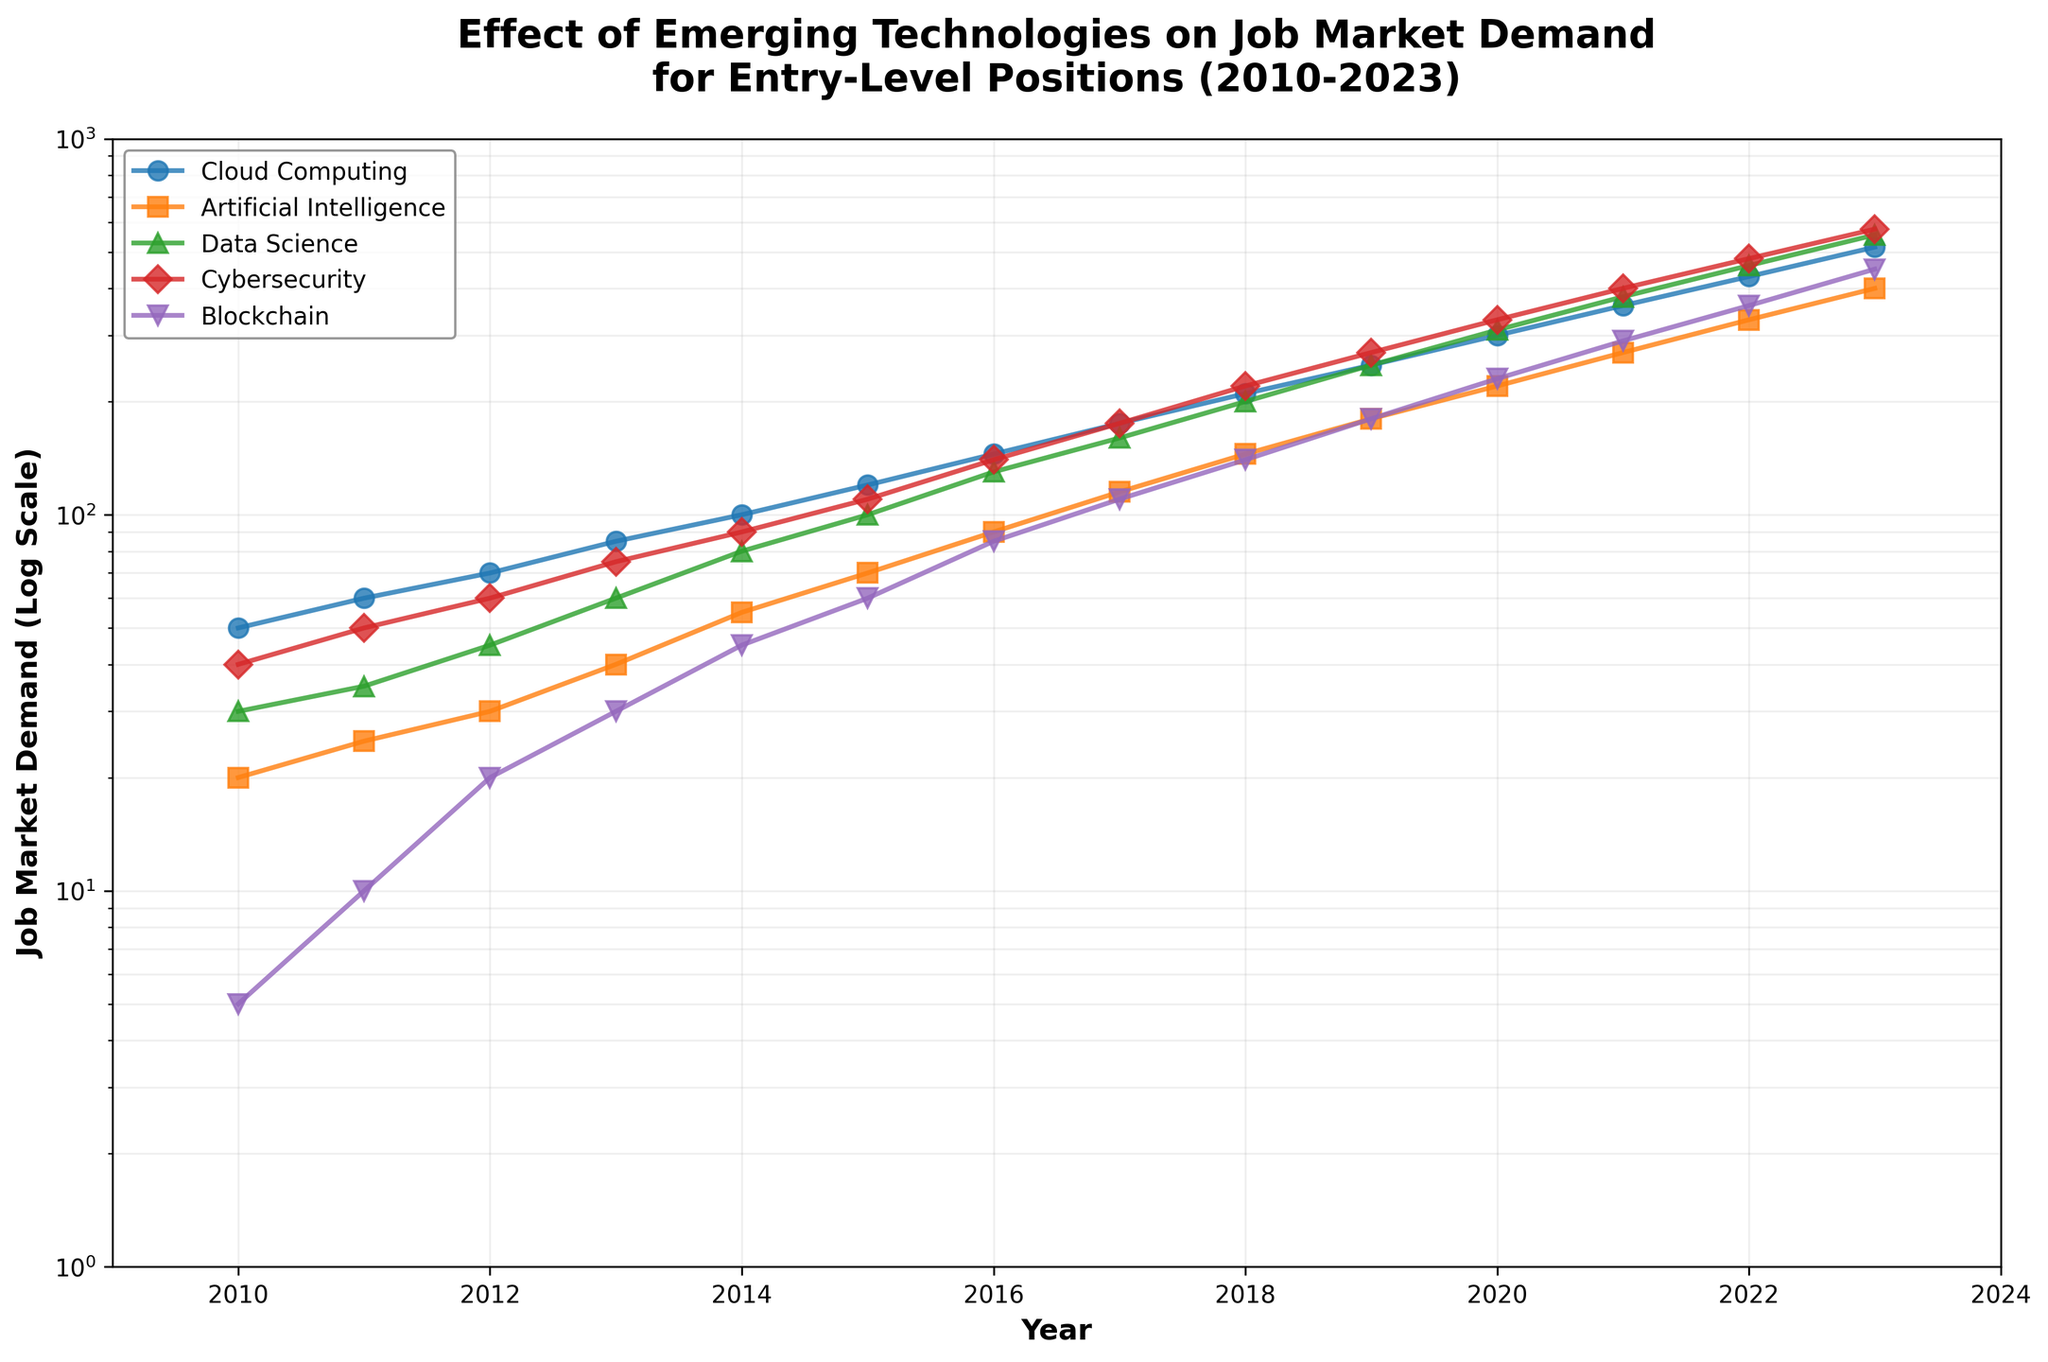What is the title of the plot? The title of the plot is displayed at the top and is typically the largest text on the figure.
Answer: Effect of Emerging Technologies on Job Market Demand for Entry-Level Positions (2010-2023) How many different technologies are shown in the plot? Count the number of different colored lines representing different technologies in the legend.
Answer: 5 Which technology shows the highest demand in 2023? Look at the values of different lines at the year 2023. The technology with the highest value is the one with the highest demand.
Answer: Cloud Computing What is the range of the y-axis in the plot? The y-axis range is indicated by the smallest and largest values shown on the y-axis.
Answer: 1 to 1000 By how much did the demand for Data Science increase from 2010 to 2023? Subtract the value of Data Science in 2010 from its value in 2023.
Answer: 525 Which technology had the smallest increase in job market demand from 2012 to 2015? Compare the differences in demand values for each technology between 2012 and 2015.
Answer: Blockchain What is the trend of Artificial Intelligence demand from 2010 to 2023 on a log scale? Observe the shape of the Artificial Intelligence line from 2010 to 2023.
Answer: Increasing exponentially Among the listed technologies, which had the highest growth rate between 2020 and 2021? Compare the slopes of the lines between 2020 and 2021 for each technology. The technology with the steepest slope has the highest growth rate.
Answer: Blockchain How does the log scale affect the appearance of the growth trends in the plot? Explain that the log scale compresses large differences and highlights exponential growth trends.
Answer: Makes exponential growth appear linear 